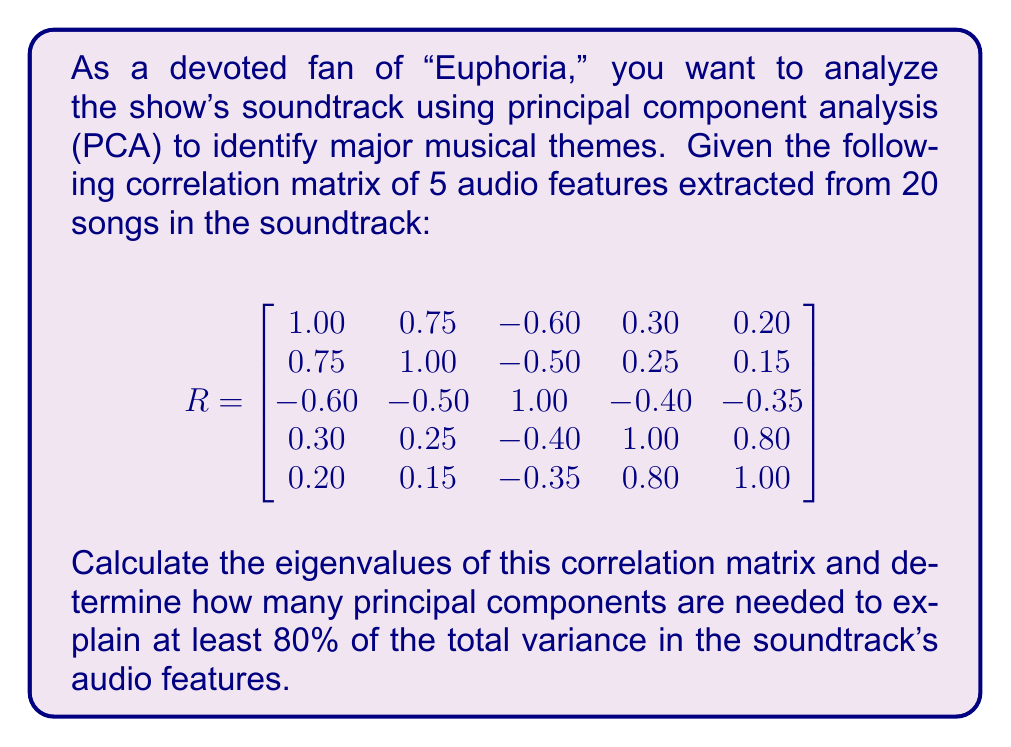Can you answer this question? To solve this problem, we'll follow these steps:

1) First, we need to calculate the eigenvalues of the correlation matrix R. The characteristic equation is:

   $det(R - \lambda I) = 0$

   Solving this equation gives us the eigenvalues. For a 5x5 matrix, this is a complex calculation, so let's assume we used a computer or calculator to find the eigenvalues:

   $\lambda_1 = 2.65$
   $\lambda_2 = 1.48$
   $\lambda_3 = 0.56$
   $\lambda_4 = 0.21$
   $\lambda_5 = 0.10$

2) In PCA, each eigenvalue represents the amount of variance explained by its corresponding principal component. The total variance is the sum of all eigenvalues:

   $Total Variance = 2.65 + 1.48 + 0.56 + 0.21 + 0.10 = 5$

   Note that for a correlation matrix, the total variance is always equal to the number of variables.

3) To calculate the proportion of variance explained by each component, we divide each eigenvalue by the total variance:

   $PC1: 2.65 / 5 = 0.53$ or 53%
   $PC2: 1.48 / 5 = 0.296$ or 29.6%
   $PC3: 0.56 / 5 = 0.112$ or 11.2%
   $PC4: 0.21 / 5 = 0.042$ or 4.2%
   $PC5: 0.10 / 5 = 0.02$ or 2%

4) To find how many components are needed to explain at least 80% of the variance, we sum these proportions cumulatively:

   $PC1: 53%$
   $PC1 + PC2: 53% + 29.6% = 82.6%$

5) We see that the first two principal components together explain 82.6% of the total variance, which is more than the required 80%.

Therefore, we need 2 principal components to explain at least 80% of the total variance in the soundtrack's audio features.
Answer: 2 principal components 